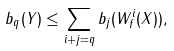<formula> <loc_0><loc_0><loc_500><loc_500>b _ { q } ( Y ) \leq \sum _ { i + j = q } b _ { j } ( W ^ { i } _ { f } ( X ) ) ,</formula> 